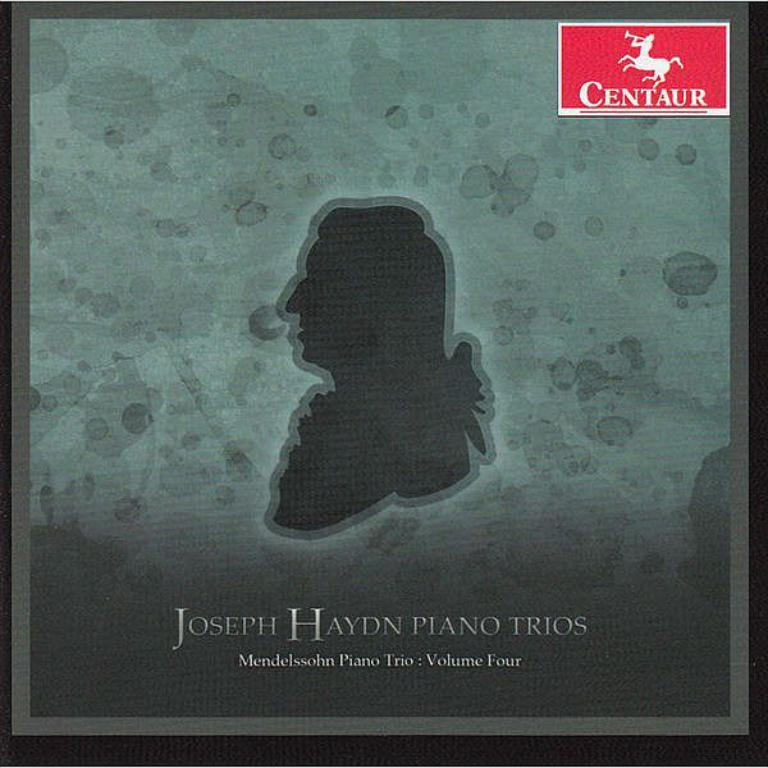Provide a one-sentence caption for the provided image. a photo of Joseph Haydn piano trios and a centaur logo. 